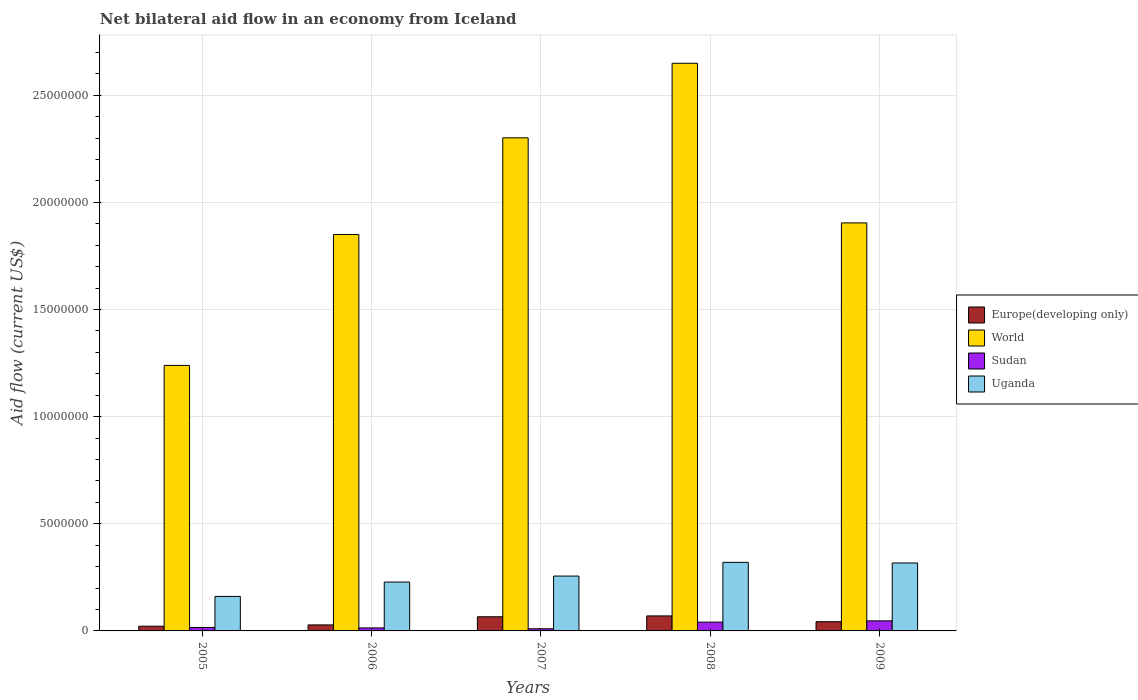How many groups of bars are there?
Offer a very short reply. 5. How many bars are there on the 4th tick from the right?
Your answer should be very brief. 4. What is the label of the 4th group of bars from the left?
Ensure brevity in your answer.  2008. In how many cases, is the number of bars for a given year not equal to the number of legend labels?
Ensure brevity in your answer.  0. What is the net bilateral aid flow in Sudan in 2005?
Ensure brevity in your answer.  1.60e+05. Across all years, what is the maximum net bilateral aid flow in Uganda?
Give a very brief answer. 3.20e+06. Across all years, what is the minimum net bilateral aid flow in Uganda?
Offer a very short reply. 1.61e+06. In which year was the net bilateral aid flow in Europe(developing only) maximum?
Ensure brevity in your answer.  2008. In which year was the net bilateral aid flow in Europe(developing only) minimum?
Offer a very short reply. 2005. What is the total net bilateral aid flow in World in the graph?
Your response must be concise. 9.94e+07. What is the difference between the net bilateral aid flow in Sudan in 2005 and that in 2009?
Your answer should be compact. -3.10e+05. What is the average net bilateral aid flow in Sudan per year?
Make the answer very short. 2.56e+05. In the year 2007, what is the difference between the net bilateral aid flow in Europe(developing only) and net bilateral aid flow in Sudan?
Keep it short and to the point. 5.60e+05. Is the net bilateral aid flow in Sudan in 2007 less than that in 2009?
Your answer should be very brief. Yes. Is the difference between the net bilateral aid flow in Europe(developing only) in 2006 and 2007 greater than the difference between the net bilateral aid flow in Sudan in 2006 and 2007?
Your response must be concise. No. What is the difference between the highest and the second highest net bilateral aid flow in World?
Your answer should be compact. 3.48e+06. What is the difference between the highest and the lowest net bilateral aid flow in Europe(developing only)?
Make the answer very short. 4.80e+05. Is the sum of the net bilateral aid flow in Sudan in 2006 and 2007 greater than the maximum net bilateral aid flow in World across all years?
Offer a very short reply. No. Is it the case that in every year, the sum of the net bilateral aid flow in Sudan and net bilateral aid flow in Europe(developing only) is greater than the sum of net bilateral aid flow in Uganda and net bilateral aid flow in World?
Offer a very short reply. Yes. What does the 1st bar from the left in 2009 represents?
Give a very brief answer. Europe(developing only). What does the 2nd bar from the right in 2007 represents?
Your response must be concise. Sudan. How many years are there in the graph?
Your answer should be very brief. 5. What is the difference between two consecutive major ticks on the Y-axis?
Your answer should be compact. 5.00e+06. Does the graph contain grids?
Make the answer very short. Yes. How many legend labels are there?
Give a very brief answer. 4. How are the legend labels stacked?
Make the answer very short. Vertical. What is the title of the graph?
Offer a terse response. Net bilateral aid flow in an economy from Iceland. Does "Marshall Islands" appear as one of the legend labels in the graph?
Provide a short and direct response. No. What is the label or title of the Y-axis?
Ensure brevity in your answer.  Aid flow (current US$). What is the Aid flow (current US$) in Europe(developing only) in 2005?
Keep it short and to the point. 2.20e+05. What is the Aid flow (current US$) in World in 2005?
Give a very brief answer. 1.24e+07. What is the Aid flow (current US$) in Uganda in 2005?
Your response must be concise. 1.61e+06. What is the Aid flow (current US$) of Europe(developing only) in 2006?
Provide a succinct answer. 2.80e+05. What is the Aid flow (current US$) of World in 2006?
Ensure brevity in your answer.  1.85e+07. What is the Aid flow (current US$) in Uganda in 2006?
Provide a succinct answer. 2.28e+06. What is the Aid flow (current US$) of World in 2007?
Your answer should be compact. 2.30e+07. What is the Aid flow (current US$) in Uganda in 2007?
Your answer should be very brief. 2.56e+06. What is the Aid flow (current US$) in World in 2008?
Give a very brief answer. 2.65e+07. What is the Aid flow (current US$) in Uganda in 2008?
Make the answer very short. 3.20e+06. What is the Aid flow (current US$) in Europe(developing only) in 2009?
Provide a short and direct response. 4.30e+05. What is the Aid flow (current US$) of World in 2009?
Keep it short and to the point. 1.90e+07. What is the Aid flow (current US$) in Sudan in 2009?
Give a very brief answer. 4.70e+05. What is the Aid flow (current US$) of Uganda in 2009?
Provide a short and direct response. 3.17e+06. Across all years, what is the maximum Aid flow (current US$) of World?
Ensure brevity in your answer.  2.65e+07. Across all years, what is the maximum Aid flow (current US$) of Uganda?
Your answer should be very brief. 3.20e+06. Across all years, what is the minimum Aid flow (current US$) in World?
Offer a very short reply. 1.24e+07. Across all years, what is the minimum Aid flow (current US$) in Sudan?
Your response must be concise. 1.00e+05. Across all years, what is the minimum Aid flow (current US$) in Uganda?
Keep it short and to the point. 1.61e+06. What is the total Aid flow (current US$) in Europe(developing only) in the graph?
Your response must be concise. 2.29e+06. What is the total Aid flow (current US$) in World in the graph?
Keep it short and to the point. 9.94e+07. What is the total Aid flow (current US$) in Sudan in the graph?
Offer a terse response. 1.28e+06. What is the total Aid flow (current US$) in Uganda in the graph?
Provide a short and direct response. 1.28e+07. What is the difference between the Aid flow (current US$) in World in 2005 and that in 2006?
Offer a terse response. -6.11e+06. What is the difference between the Aid flow (current US$) in Uganda in 2005 and that in 2006?
Your response must be concise. -6.70e+05. What is the difference between the Aid flow (current US$) of Europe(developing only) in 2005 and that in 2007?
Keep it short and to the point. -4.40e+05. What is the difference between the Aid flow (current US$) of World in 2005 and that in 2007?
Offer a terse response. -1.06e+07. What is the difference between the Aid flow (current US$) of Sudan in 2005 and that in 2007?
Your response must be concise. 6.00e+04. What is the difference between the Aid flow (current US$) in Uganda in 2005 and that in 2007?
Keep it short and to the point. -9.50e+05. What is the difference between the Aid flow (current US$) in Europe(developing only) in 2005 and that in 2008?
Make the answer very short. -4.80e+05. What is the difference between the Aid flow (current US$) in World in 2005 and that in 2008?
Your response must be concise. -1.41e+07. What is the difference between the Aid flow (current US$) of Sudan in 2005 and that in 2008?
Provide a succinct answer. -2.50e+05. What is the difference between the Aid flow (current US$) in Uganda in 2005 and that in 2008?
Offer a terse response. -1.59e+06. What is the difference between the Aid flow (current US$) in Europe(developing only) in 2005 and that in 2009?
Your response must be concise. -2.10e+05. What is the difference between the Aid flow (current US$) in World in 2005 and that in 2009?
Keep it short and to the point. -6.65e+06. What is the difference between the Aid flow (current US$) of Sudan in 2005 and that in 2009?
Give a very brief answer. -3.10e+05. What is the difference between the Aid flow (current US$) in Uganda in 2005 and that in 2009?
Your answer should be compact. -1.56e+06. What is the difference between the Aid flow (current US$) in Europe(developing only) in 2006 and that in 2007?
Keep it short and to the point. -3.80e+05. What is the difference between the Aid flow (current US$) in World in 2006 and that in 2007?
Give a very brief answer. -4.51e+06. What is the difference between the Aid flow (current US$) in Uganda in 2006 and that in 2007?
Your response must be concise. -2.80e+05. What is the difference between the Aid flow (current US$) in Europe(developing only) in 2006 and that in 2008?
Offer a terse response. -4.20e+05. What is the difference between the Aid flow (current US$) of World in 2006 and that in 2008?
Give a very brief answer. -7.99e+06. What is the difference between the Aid flow (current US$) of Uganda in 2006 and that in 2008?
Your answer should be very brief. -9.20e+05. What is the difference between the Aid flow (current US$) in World in 2006 and that in 2009?
Your response must be concise. -5.40e+05. What is the difference between the Aid flow (current US$) of Sudan in 2006 and that in 2009?
Provide a succinct answer. -3.30e+05. What is the difference between the Aid flow (current US$) in Uganda in 2006 and that in 2009?
Your answer should be compact. -8.90e+05. What is the difference between the Aid flow (current US$) in World in 2007 and that in 2008?
Ensure brevity in your answer.  -3.48e+06. What is the difference between the Aid flow (current US$) in Sudan in 2007 and that in 2008?
Your answer should be very brief. -3.10e+05. What is the difference between the Aid flow (current US$) of Uganda in 2007 and that in 2008?
Give a very brief answer. -6.40e+05. What is the difference between the Aid flow (current US$) in World in 2007 and that in 2009?
Make the answer very short. 3.97e+06. What is the difference between the Aid flow (current US$) of Sudan in 2007 and that in 2009?
Make the answer very short. -3.70e+05. What is the difference between the Aid flow (current US$) in Uganda in 2007 and that in 2009?
Offer a terse response. -6.10e+05. What is the difference between the Aid flow (current US$) in Europe(developing only) in 2008 and that in 2009?
Offer a terse response. 2.70e+05. What is the difference between the Aid flow (current US$) in World in 2008 and that in 2009?
Provide a succinct answer. 7.45e+06. What is the difference between the Aid flow (current US$) in Sudan in 2008 and that in 2009?
Offer a very short reply. -6.00e+04. What is the difference between the Aid flow (current US$) of Uganda in 2008 and that in 2009?
Provide a short and direct response. 3.00e+04. What is the difference between the Aid flow (current US$) in Europe(developing only) in 2005 and the Aid flow (current US$) in World in 2006?
Provide a succinct answer. -1.83e+07. What is the difference between the Aid flow (current US$) of Europe(developing only) in 2005 and the Aid flow (current US$) of Sudan in 2006?
Give a very brief answer. 8.00e+04. What is the difference between the Aid flow (current US$) of Europe(developing only) in 2005 and the Aid flow (current US$) of Uganda in 2006?
Offer a terse response. -2.06e+06. What is the difference between the Aid flow (current US$) in World in 2005 and the Aid flow (current US$) in Sudan in 2006?
Make the answer very short. 1.22e+07. What is the difference between the Aid flow (current US$) in World in 2005 and the Aid flow (current US$) in Uganda in 2006?
Offer a terse response. 1.01e+07. What is the difference between the Aid flow (current US$) of Sudan in 2005 and the Aid flow (current US$) of Uganda in 2006?
Give a very brief answer. -2.12e+06. What is the difference between the Aid flow (current US$) of Europe(developing only) in 2005 and the Aid flow (current US$) of World in 2007?
Keep it short and to the point. -2.28e+07. What is the difference between the Aid flow (current US$) of Europe(developing only) in 2005 and the Aid flow (current US$) of Sudan in 2007?
Your answer should be compact. 1.20e+05. What is the difference between the Aid flow (current US$) in Europe(developing only) in 2005 and the Aid flow (current US$) in Uganda in 2007?
Keep it short and to the point. -2.34e+06. What is the difference between the Aid flow (current US$) in World in 2005 and the Aid flow (current US$) in Sudan in 2007?
Provide a succinct answer. 1.23e+07. What is the difference between the Aid flow (current US$) of World in 2005 and the Aid flow (current US$) of Uganda in 2007?
Keep it short and to the point. 9.83e+06. What is the difference between the Aid flow (current US$) of Sudan in 2005 and the Aid flow (current US$) of Uganda in 2007?
Your answer should be very brief. -2.40e+06. What is the difference between the Aid flow (current US$) of Europe(developing only) in 2005 and the Aid flow (current US$) of World in 2008?
Provide a succinct answer. -2.63e+07. What is the difference between the Aid flow (current US$) of Europe(developing only) in 2005 and the Aid flow (current US$) of Uganda in 2008?
Provide a succinct answer. -2.98e+06. What is the difference between the Aid flow (current US$) of World in 2005 and the Aid flow (current US$) of Sudan in 2008?
Your answer should be compact. 1.20e+07. What is the difference between the Aid flow (current US$) of World in 2005 and the Aid flow (current US$) of Uganda in 2008?
Your answer should be very brief. 9.19e+06. What is the difference between the Aid flow (current US$) of Sudan in 2005 and the Aid flow (current US$) of Uganda in 2008?
Ensure brevity in your answer.  -3.04e+06. What is the difference between the Aid flow (current US$) in Europe(developing only) in 2005 and the Aid flow (current US$) in World in 2009?
Your answer should be compact. -1.88e+07. What is the difference between the Aid flow (current US$) of Europe(developing only) in 2005 and the Aid flow (current US$) of Uganda in 2009?
Offer a very short reply. -2.95e+06. What is the difference between the Aid flow (current US$) in World in 2005 and the Aid flow (current US$) in Sudan in 2009?
Provide a short and direct response. 1.19e+07. What is the difference between the Aid flow (current US$) in World in 2005 and the Aid flow (current US$) in Uganda in 2009?
Your response must be concise. 9.22e+06. What is the difference between the Aid flow (current US$) of Sudan in 2005 and the Aid flow (current US$) of Uganda in 2009?
Offer a very short reply. -3.01e+06. What is the difference between the Aid flow (current US$) in Europe(developing only) in 2006 and the Aid flow (current US$) in World in 2007?
Your response must be concise. -2.27e+07. What is the difference between the Aid flow (current US$) in Europe(developing only) in 2006 and the Aid flow (current US$) in Sudan in 2007?
Offer a terse response. 1.80e+05. What is the difference between the Aid flow (current US$) in Europe(developing only) in 2006 and the Aid flow (current US$) in Uganda in 2007?
Your answer should be very brief. -2.28e+06. What is the difference between the Aid flow (current US$) of World in 2006 and the Aid flow (current US$) of Sudan in 2007?
Ensure brevity in your answer.  1.84e+07. What is the difference between the Aid flow (current US$) of World in 2006 and the Aid flow (current US$) of Uganda in 2007?
Make the answer very short. 1.59e+07. What is the difference between the Aid flow (current US$) of Sudan in 2006 and the Aid flow (current US$) of Uganda in 2007?
Your response must be concise. -2.42e+06. What is the difference between the Aid flow (current US$) of Europe(developing only) in 2006 and the Aid flow (current US$) of World in 2008?
Give a very brief answer. -2.62e+07. What is the difference between the Aid flow (current US$) in Europe(developing only) in 2006 and the Aid flow (current US$) in Uganda in 2008?
Offer a terse response. -2.92e+06. What is the difference between the Aid flow (current US$) in World in 2006 and the Aid flow (current US$) in Sudan in 2008?
Your response must be concise. 1.81e+07. What is the difference between the Aid flow (current US$) of World in 2006 and the Aid flow (current US$) of Uganda in 2008?
Make the answer very short. 1.53e+07. What is the difference between the Aid flow (current US$) of Sudan in 2006 and the Aid flow (current US$) of Uganda in 2008?
Make the answer very short. -3.06e+06. What is the difference between the Aid flow (current US$) in Europe(developing only) in 2006 and the Aid flow (current US$) in World in 2009?
Keep it short and to the point. -1.88e+07. What is the difference between the Aid flow (current US$) of Europe(developing only) in 2006 and the Aid flow (current US$) of Uganda in 2009?
Keep it short and to the point. -2.89e+06. What is the difference between the Aid flow (current US$) of World in 2006 and the Aid flow (current US$) of Sudan in 2009?
Give a very brief answer. 1.80e+07. What is the difference between the Aid flow (current US$) of World in 2006 and the Aid flow (current US$) of Uganda in 2009?
Provide a short and direct response. 1.53e+07. What is the difference between the Aid flow (current US$) of Sudan in 2006 and the Aid flow (current US$) of Uganda in 2009?
Offer a terse response. -3.03e+06. What is the difference between the Aid flow (current US$) in Europe(developing only) in 2007 and the Aid flow (current US$) in World in 2008?
Ensure brevity in your answer.  -2.58e+07. What is the difference between the Aid flow (current US$) in Europe(developing only) in 2007 and the Aid flow (current US$) in Sudan in 2008?
Give a very brief answer. 2.50e+05. What is the difference between the Aid flow (current US$) in Europe(developing only) in 2007 and the Aid flow (current US$) in Uganda in 2008?
Provide a succinct answer. -2.54e+06. What is the difference between the Aid flow (current US$) in World in 2007 and the Aid flow (current US$) in Sudan in 2008?
Offer a terse response. 2.26e+07. What is the difference between the Aid flow (current US$) of World in 2007 and the Aid flow (current US$) of Uganda in 2008?
Make the answer very short. 1.98e+07. What is the difference between the Aid flow (current US$) of Sudan in 2007 and the Aid flow (current US$) of Uganda in 2008?
Ensure brevity in your answer.  -3.10e+06. What is the difference between the Aid flow (current US$) in Europe(developing only) in 2007 and the Aid flow (current US$) in World in 2009?
Your answer should be very brief. -1.84e+07. What is the difference between the Aid flow (current US$) in Europe(developing only) in 2007 and the Aid flow (current US$) in Uganda in 2009?
Your response must be concise. -2.51e+06. What is the difference between the Aid flow (current US$) of World in 2007 and the Aid flow (current US$) of Sudan in 2009?
Your answer should be very brief. 2.25e+07. What is the difference between the Aid flow (current US$) of World in 2007 and the Aid flow (current US$) of Uganda in 2009?
Your response must be concise. 1.98e+07. What is the difference between the Aid flow (current US$) of Sudan in 2007 and the Aid flow (current US$) of Uganda in 2009?
Keep it short and to the point. -3.07e+06. What is the difference between the Aid flow (current US$) in Europe(developing only) in 2008 and the Aid flow (current US$) in World in 2009?
Provide a short and direct response. -1.83e+07. What is the difference between the Aid flow (current US$) of Europe(developing only) in 2008 and the Aid flow (current US$) of Sudan in 2009?
Ensure brevity in your answer.  2.30e+05. What is the difference between the Aid flow (current US$) in Europe(developing only) in 2008 and the Aid flow (current US$) in Uganda in 2009?
Your answer should be compact. -2.47e+06. What is the difference between the Aid flow (current US$) in World in 2008 and the Aid flow (current US$) in Sudan in 2009?
Provide a short and direct response. 2.60e+07. What is the difference between the Aid flow (current US$) of World in 2008 and the Aid flow (current US$) of Uganda in 2009?
Make the answer very short. 2.33e+07. What is the difference between the Aid flow (current US$) of Sudan in 2008 and the Aid flow (current US$) of Uganda in 2009?
Provide a succinct answer. -2.76e+06. What is the average Aid flow (current US$) in Europe(developing only) per year?
Give a very brief answer. 4.58e+05. What is the average Aid flow (current US$) in World per year?
Ensure brevity in your answer.  1.99e+07. What is the average Aid flow (current US$) of Sudan per year?
Make the answer very short. 2.56e+05. What is the average Aid flow (current US$) in Uganda per year?
Ensure brevity in your answer.  2.56e+06. In the year 2005, what is the difference between the Aid flow (current US$) in Europe(developing only) and Aid flow (current US$) in World?
Your answer should be very brief. -1.22e+07. In the year 2005, what is the difference between the Aid flow (current US$) in Europe(developing only) and Aid flow (current US$) in Uganda?
Make the answer very short. -1.39e+06. In the year 2005, what is the difference between the Aid flow (current US$) of World and Aid flow (current US$) of Sudan?
Keep it short and to the point. 1.22e+07. In the year 2005, what is the difference between the Aid flow (current US$) in World and Aid flow (current US$) in Uganda?
Your answer should be compact. 1.08e+07. In the year 2005, what is the difference between the Aid flow (current US$) in Sudan and Aid flow (current US$) in Uganda?
Offer a very short reply. -1.45e+06. In the year 2006, what is the difference between the Aid flow (current US$) in Europe(developing only) and Aid flow (current US$) in World?
Provide a succinct answer. -1.82e+07. In the year 2006, what is the difference between the Aid flow (current US$) of World and Aid flow (current US$) of Sudan?
Your response must be concise. 1.84e+07. In the year 2006, what is the difference between the Aid flow (current US$) of World and Aid flow (current US$) of Uganda?
Your response must be concise. 1.62e+07. In the year 2006, what is the difference between the Aid flow (current US$) of Sudan and Aid flow (current US$) of Uganda?
Offer a terse response. -2.14e+06. In the year 2007, what is the difference between the Aid flow (current US$) of Europe(developing only) and Aid flow (current US$) of World?
Give a very brief answer. -2.24e+07. In the year 2007, what is the difference between the Aid flow (current US$) of Europe(developing only) and Aid flow (current US$) of Sudan?
Your answer should be compact. 5.60e+05. In the year 2007, what is the difference between the Aid flow (current US$) of Europe(developing only) and Aid flow (current US$) of Uganda?
Ensure brevity in your answer.  -1.90e+06. In the year 2007, what is the difference between the Aid flow (current US$) in World and Aid flow (current US$) in Sudan?
Your response must be concise. 2.29e+07. In the year 2007, what is the difference between the Aid flow (current US$) in World and Aid flow (current US$) in Uganda?
Ensure brevity in your answer.  2.04e+07. In the year 2007, what is the difference between the Aid flow (current US$) in Sudan and Aid flow (current US$) in Uganda?
Provide a short and direct response. -2.46e+06. In the year 2008, what is the difference between the Aid flow (current US$) in Europe(developing only) and Aid flow (current US$) in World?
Offer a very short reply. -2.58e+07. In the year 2008, what is the difference between the Aid flow (current US$) in Europe(developing only) and Aid flow (current US$) in Uganda?
Your answer should be compact. -2.50e+06. In the year 2008, what is the difference between the Aid flow (current US$) in World and Aid flow (current US$) in Sudan?
Provide a succinct answer. 2.61e+07. In the year 2008, what is the difference between the Aid flow (current US$) in World and Aid flow (current US$) in Uganda?
Offer a very short reply. 2.33e+07. In the year 2008, what is the difference between the Aid flow (current US$) in Sudan and Aid flow (current US$) in Uganda?
Offer a very short reply. -2.79e+06. In the year 2009, what is the difference between the Aid flow (current US$) in Europe(developing only) and Aid flow (current US$) in World?
Your answer should be compact. -1.86e+07. In the year 2009, what is the difference between the Aid flow (current US$) of Europe(developing only) and Aid flow (current US$) of Uganda?
Offer a terse response. -2.74e+06. In the year 2009, what is the difference between the Aid flow (current US$) of World and Aid flow (current US$) of Sudan?
Your answer should be very brief. 1.86e+07. In the year 2009, what is the difference between the Aid flow (current US$) in World and Aid flow (current US$) in Uganda?
Provide a succinct answer. 1.59e+07. In the year 2009, what is the difference between the Aid flow (current US$) of Sudan and Aid flow (current US$) of Uganda?
Ensure brevity in your answer.  -2.70e+06. What is the ratio of the Aid flow (current US$) of Europe(developing only) in 2005 to that in 2006?
Give a very brief answer. 0.79. What is the ratio of the Aid flow (current US$) in World in 2005 to that in 2006?
Provide a succinct answer. 0.67. What is the ratio of the Aid flow (current US$) of Uganda in 2005 to that in 2006?
Your answer should be compact. 0.71. What is the ratio of the Aid flow (current US$) of World in 2005 to that in 2007?
Provide a short and direct response. 0.54. What is the ratio of the Aid flow (current US$) in Uganda in 2005 to that in 2007?
Your answer should be very brief. 0.63. What is the ratio of the Aid flow (current US$) of Europe(developing only) in 2005 to that in 2008?
Provide a short and direct response. 0.31. What is the ratio of the Aid flow (current US$) of World in 2005 to that in 2008?
Provide a short and direct response. 0.47. What is the ratio of the Aid flow (current US$) in Sudan in 2005 to that in 2008?
Ensure brevity in your answer.  0.39. What is the ratio of the Aid flow (current US$) in Uganda in 2005 to that in 2008?
Provide a short and direct response. 0.5. What is the ratio of the Aid flow (current US$) in Europe(developing only) in 2005 to that in 2009?
Provide a short and direct response. 0.51. What is the ratio of the Aid flow (current US$) in World in 2005 to that in 2009?
Keep it short and to the point. 0.65. What is the ratio of the Aid flow (current US$) of Sudan in 2005 to that in 2009?
Provide a succinct answer. 0.34. What is the ratio of the Aid flow (current US$) in Uganda in 2005 to that in 2009?
Your response must be concise. 0.51. What is the ratio of the Aid flow (current US$) in Europe(developing only) in 2006 to that in 2007?
Provide a short and direct response. 0.42. What is the ratio of the Aid flow (current US$) of World in 2006 to that in 2007?
Provide a succinct answer. 0.8. What is the ratio of the Aid flow (current US$) of Uganda in 2006 to that in 2007?
Keep it short and to the point. 0.89. What is the ratio of the Aid flow (current US$) in World in 2006 to that in 2008?
Your answer should be compact. 0.7. What is the ratio of the Aid flow (current US$) in Sudan in 2006 to that in 2008?
Offer a terse response. 0.34. What is the ratio of the Aid flow (current US$) in Uganda in 2006 to that in 2008?
Offer a very short reply. 0.71. What is the ratio of the Aid flow (current US$) of Europe(developing only) in 2006 to that in 2009?
Provide a short and direct response. 0.65. What is the ratio of the Aid flow (current US$) of World in 2006 to that in 2009?
Your answer should be compact. 0.97. What is the ratio of the Aid flow (current US$) of Sudan in 2006 to that in 2009?
Provide a short and direct response. 0.3. What is the ratio of the Aid flow (current US$) of Uganda in 2006 to that in 2009?
Ensure brevity in your answer.  0.72. What is the ratio of the Aid flow (current US$) in Europe(developing only) in 2007 to that in 2008?
Ensure brevity in your answer.  0.94. What is the ratio of the Aid flow (current US$) of World in 2007 to that in 2008?
Offer a very short reply. 0.87. What is the ratio of the Aid flow (current US$) in Sudan in 2007 to that in 2008?
Keep it short and to the point. 0.24. What is the ratio of the Aid flow (current US$) of Europe(developing only) in 2007 to that in 2009?
Ensure brevity in your answer.  1.53. What is the ratio of the Aid flow (current US$) of World in 2007 to that in 2009?
Your answer should be compact. 1.21. What is the ratio of the Aid flow (current US$) in Sudan in 2007 to that in 2009?
Provide a short and direct response. 0.21. What is the ratio of the Aid flow (current US$) in Uganda in 2007 to that in 2009?
Give a very brief answer. 0.81. What is the ratio of the Aid flow (current US$) of Europe(developing only) in 2008 to that in 2009?
Ensure brevity in your answer.  1.63. What is the ratio of the Aid flow (current US$) in World in 2008 to that in 2009?
Offer a very short reply. 1.39. What is the ratio of the Aid flow (current US$) of Sudan in 2008 to that in 2009?
Provide a succinct answer. 0.87. What is the ratio of the Aid flow (current US$) in Uganda in 2008 to that in 2009?
Offer a very short reply. 1.01. What is the difference between the highest and the second highest Aid flow (current US$) in Europe(developing only)?
Your response must be concise. 4.00e+04. What is the difference between the highest and the second highest Aid flow (current US$) in World?
Offer a terse response. 3.48e+06. What is the difference between the highest and the second highest Aid flow (current US$) in Uganda?
Make the answer very short. 3.00e+04. What is the difference between the highest and the lowest Aid flow (current US$) in Europe(developing only)?
Your answer should be compact. 4.80e+05. What is the difference between the highest and the lowest Aid flow (current US$) of World?
Offer a terse response. 1.41e+07. What is the difference between the highest and the lowest Aid flow (current US$) of Uganda?
Provide a short and direct response. 1.59e+06. 